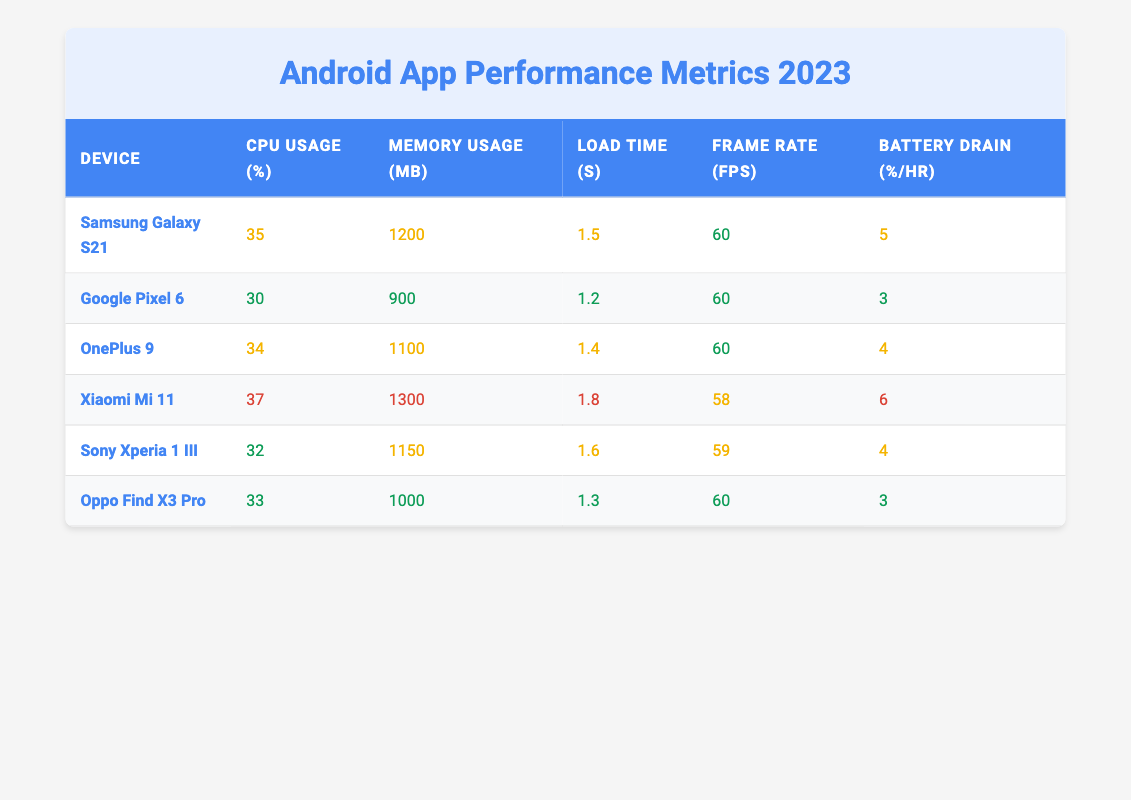What is the CPU usage of the Google Pixel 6? The table lists the CPU usage for the Google Pixel 6 as 30%. It can be directly found in the "CPU Usage (%)" column corresponding to the device name in the first column.
Answer: 30 Which device has the highest memory usage? By comparing the memory usage values from each row, the Xiaomi Mi 11 has the highest memory usage listed at 1300 MB.
Answer: Xiaomi Mi 11 What is the average load time of all devices listed? To calculate the average load time, sum all the load times: 1.5 + 1.2 + 1.4 + 1.8 + 1.6 + 1.3 = 9.8 seconds. There are 6 devices, so the average load time is 9.8 / 6 = 1.6333 seconds (approximately 1.63 seconds).
Answer: 1.63 Is the frame rate of the OnePlus 9 higher than that of the Xiaomi Mi 11? The frame rate for OnePlus 9 is 60 FPS, whereas for Xiaomi Mi 11 it is 58 FPS. Since 60 is greater than 58, the statement is true.
Answer: Yes What is the total battery drain percentage per hour for all devices combined? Adding the battery drain percentages: 5 + 3 + 4 + 6 + 4 + 3 = 25%. This is the total battery drain across all devices.
Answer: 25 Which device has the best battery drain performance? The best battery drain performance identifies the device with the lowest percentage. The Google Pixel 6 and Oppo Find X3 Pro both have the lowest at 3%, indicating these devices drain the least battery per hour.
Answer: Google Pixel 6, Oppo Find X3 Pro For devices with a frame rate of 60 FPS, what is their average load time? The devices with a frame rate of 60 FPS are Google Pixel 6, OnePlus 9, and Oppo Find X3 Pro. Their load times are 1.2, 1.4, and 1.3 seconds respectively. Adding these gives 1.2 + 1.4 + 1.3 = 3.9 seconds. Dividing by 3 (the number of devices), the average load time is 3.9 / 3 = 1.3 seconds.
Answer: 1.3 Is it true that the Samsung Galaxy S21 has a higher CPU usage than the Oppo Find X3 Pro? The CPU usage for Samsung Galaxy S21 is 35%, which is higher than the 33% usage of Oppo Find X3 Pro. The statement is true based on these comparisons.
Answer: Yes What is the difference in battery drain between the best and worst-performing devices? The best performance is from the Google Pixel 6 and Oppo Find X3 Pro at 3%, while the worst-performing device is Xiaomi Mi 11 at 6%. The difference is 6 - 3 = 3% in battery drain.
Answer: 3 